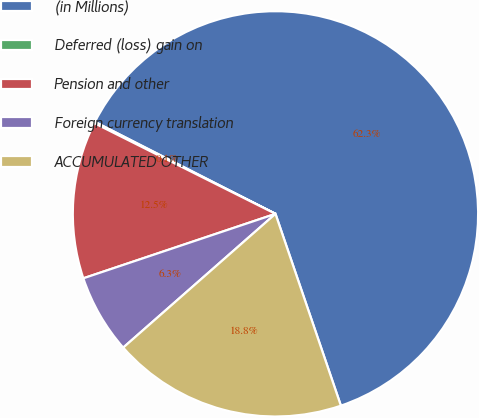Convert chart. <chart><loc_0><loc_0><loc_500><loc_500><pie_chart><fcel>(in Millions)<fcel>Deferred (loss) gain on<fcel>Pension and other<fcel>Foreign currency translation<fcel>ACCUMULATED OTHER<nl><fcel>62.27%<fcel>0.11%<fcel>12.54%<fcel>6.32%<fcel>18.76%<nl></chart> 